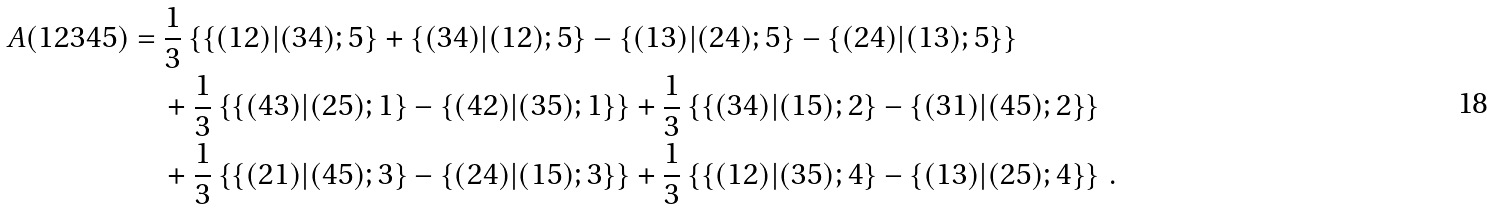Convert formula to latex. <formula><loc_0><loc_0><loc_500><loc_500>A ( 1 2 3 4 5 ) & = \frac { 1 } { 3 } \left \{ \{ ( 1 2 ) | ( 3 4 ) ; 5 \} + \{ ( 3 4 ) | ( 1 2 ) ; 5 \} - \{ ( 1 3 ) | ( 2 4 ) ; 5 \} - \{ ( 2 4 ) | ( 1 3 ) ; 5 \} \right \} \\ & \quad + \frac { 1 } { 3 } \left \{ \{ ( 4 3 ) | ( 2 5 ) ; 1 \} - \{ ( 4 2 ) | ( 3 5 ) ; 1 \} \right \} + \frac { 1 } { 3 } \left \{ \{ ( 3 4 ) | ( 1 5 ) ; 2 \} - \{ ( 3 1 ) | ( 4 5 ) ; 2 \} \right \} \\ & \quad + \frac { 1 } { 3 } \left \{ \{ ( 2 1 ) | ( 4 5 ) ; 3 \} - \{ ( 2 4 ) | ( 1 5 ) ; 3 \} \right \} + \frac { 1 } { 3 } \left \{ \{ ( 1 2 ) | ( 3 5 ) ; 4 \} - \{ ( 1 3 ) | ( 2 5 ) ; 4 \} \right \} \, .</formula> 